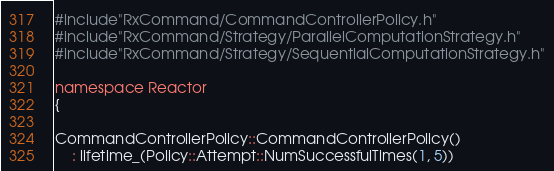Convert code to text. <code><loc_0><loc_0><loc_500><loc_500><_C++_>#include"RxCommand/CommandControllerPolicy.h"
#include"RxCommand/Strategy/ParallelComputationStrategy.h"
#include"RxCommand/Strategy/SequentialComputationStrategy.h"

namespace Reactor
{

CommandControllerPolicy::CommandControllerPolicy()
    : lifetime_(Policy::Attempt::NumSuccessfulTimes(1, 5))</code> 